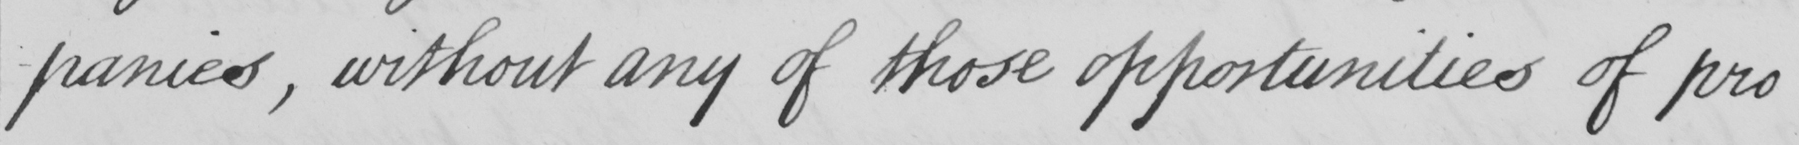Transcribe the text shown in this historical manuscript line. panies, without any of those opportunities of pro 